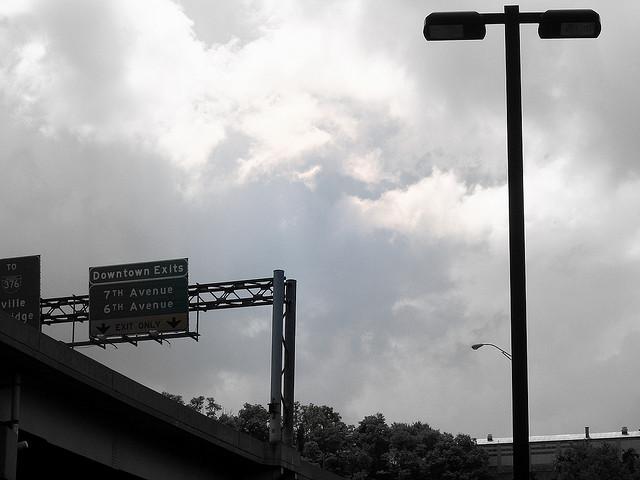Is this Veterans Bridge in Pittsburgh Pennsylvania?
Quick response, please. Yes. What is the weather?
Answer briefly. Cloudy. How much higher in feet does he have to jump to reach the top of the pole?
Give a very brief answer. 20. How do people commute on the bridge?
Write a very short answer. Car. Is the sky extremely cloudy?
Write a very short answer. Yes. Are there many clouds in the sky?
Quick response, please. Yes. What things are hanging from the pole?
Concise answer only. Lights. Is the sky blue?
Answer briefly. No. What does the upper right sign say?
Answer briefly. Downtown exits. 